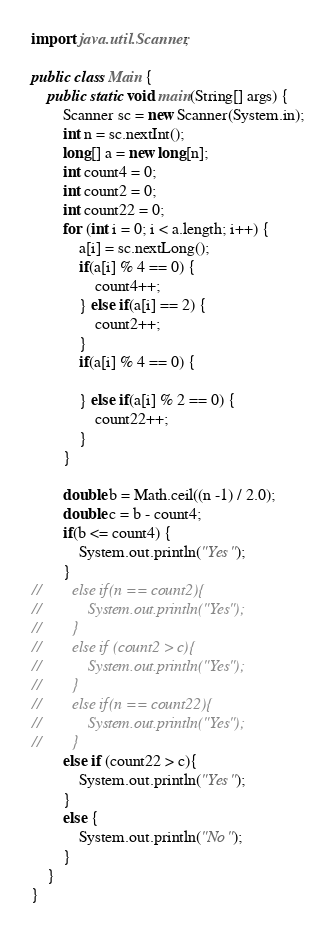<code> <loc_0><loc_0><loc_500><loc_500><_Java_>import java.util.Scanner;

public class Main {
    public static void main(String[] args) {
        Scanner sc = new Scanner(System.in);
        int n = sc.nextInt();
        long[] a = new long[n];
        int count4 = 0;
        int count2 = 0;
        int count22 = 0;
        for (int i = 0; i < a.length; i++) {
            a[i] = sc.nextLong();
            if(a[i] % 4 == 0) {
                count4++;
            } else if(a[i] == 2) {
                count2++;
            }
            if(a[i] % 4 == 0) {

            } else if(a[i] % 2 == 0) {
                count22++;
            }
        }

        double b = Math.ceil((n -1) / 2.0);
        double c = b - count4;
        if(b <= count4) {
            System.out.println("Yes");
        }
//        else if(n == count2){
//            System.out.println("Yes");
//        }
//        else if (count2 > c){
//            System.out.println("Yes");
//        }
//        else if(n == count22){
//            System.out.println("Yes");
//        }
        else if (count22 > c){
            System.out.println("Yes");
        }
        else {
            System.out.println("No");
        }
    }
}</code> 